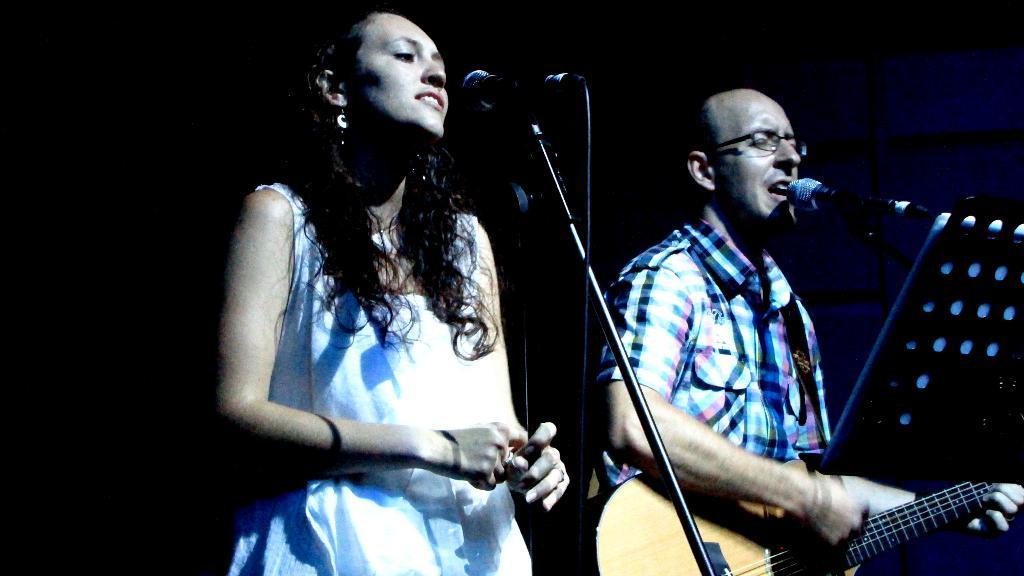Can you describe this image briefly? A woman standing and smiling. In front of her there is a mic and mic stand. Beside her a person wearing specs is singing and holding guitar. In front of him there is a mic and mic stand. 